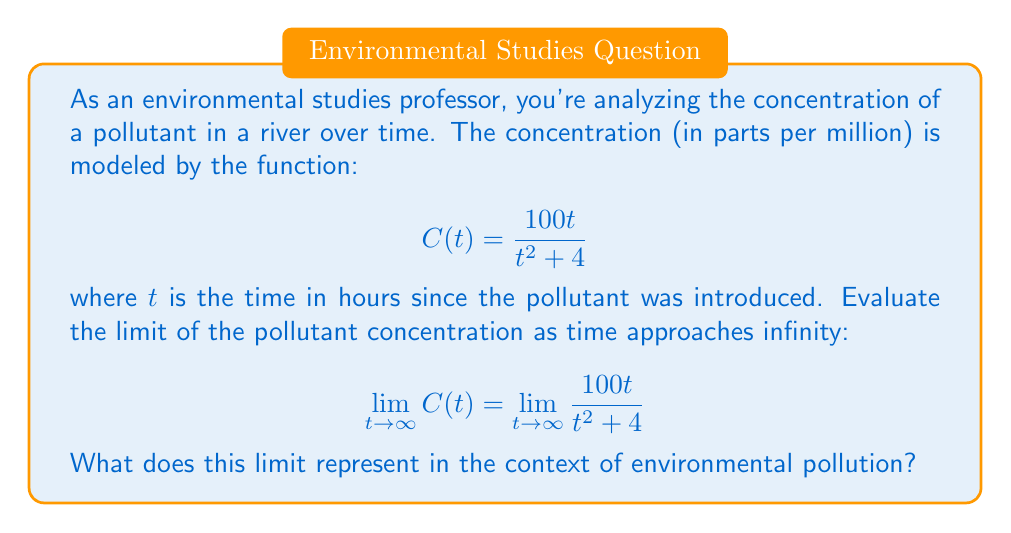Give your solution to this math problem. Let's approach this step-by-step:

1) To evaluate the limit as $t$ approaches infinity, we need to consider the behavior of the numerator and denominator separately.

2) In the numerator, we have $100t$, which grows linearly with $t$.

3) In the denominator, we have $t^2 + 4$, which grows quadratically with $t$.

4) As $t$ becomes very large, the $4$ in the denominator becomes negligible compared to $t^2$. So, for large $t$, our function behaves similarly to:

   $$\frac{100t}{t^2} = \frac{100}{t}$$

5) To formalize this, we can divide both numerator and denominator by the highest power of $t$ in the denominator, which is $t^2$:

   $$\lim_{t \to \infty} \frac{100t}{t^2 + 4} = \lim_{t \to \infty} \frac{100t/t^2}{(t^2 + 4)/t^2} = \lim_{t \to \infty} \frac{100/t}{1 + 4/t^2}$$

6) As $t$ approaches infinity, $1/t$ and $4/t^2$ both approach 0:

   $$\lim_{t \to \infty} \frac{100/t}{1 + 4/t^2} = \frac{0}{1 + 0} = 0$$

7) In the context of environmental pollution, this limit represents the long-term behavior of the pollutant concentration. The limit being 0 indicates that the concentration of the pollutant approaches 0 as time goes to infinity, suggesting that the pollutant gradually dissipates or is diluted in the river over time.
Answer: 0 